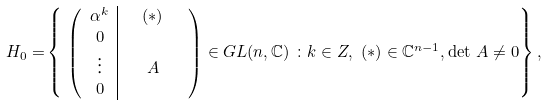<formula> <loc_0><loc_0><loc_500><loc_500>H _ { 0 } = & \left \{ \ \left ( \begin{array} { c | c c c c } \alpha ^ { k } & & ( * ) & \\ 0 & \\ \vdots & & A \\ 0 & & \end{array} \right ) \in G L ( n , { \mathbb { C } } ) \ \colon k \in { Z } , \ ( * ) \in { \mathbb { C } } ^ { n - 1 } , \det \, A \ne 0 \right \} ,</formula> 